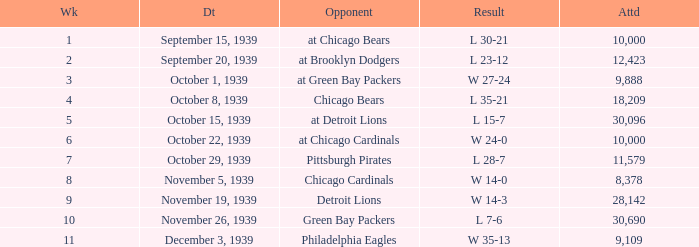What sum of Attendance has a Week smaller than 10, and a Result of l 30-21? 10000.0. 